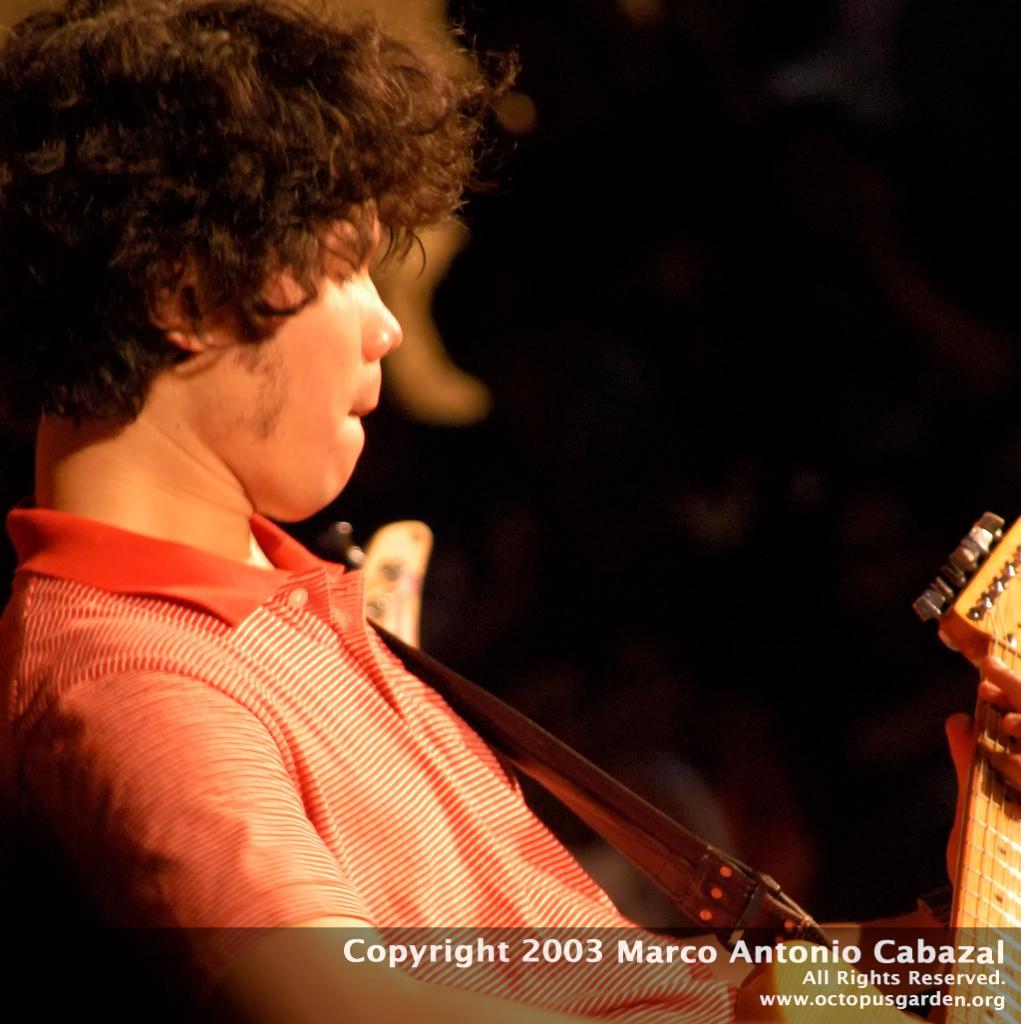Please provide a concise description of this image. In this image we can see a person playing a guitar and some text in the bottom of the image and a dark background. 